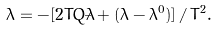Convert formula to latex. <formula><loc_0><loc_0><loc_500><loc_500>\ddot { \lambda } = - [ 2 T Q \dot { \lambda } + ( \lambda - \lambda ^ { 0 } ) ] \, / \, T ^ { 2 } .</formula> 